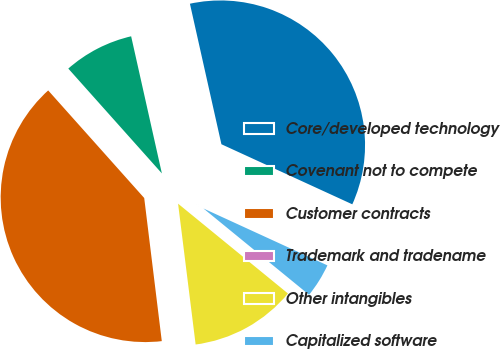Convert chart. <chart><loc_0><loc_0><loc_500><loc_500><pie_chart><fcel>Core/developed technology<fcel>Covenant not to compete<fcel>Customer contracts<fcel>Trademark and tradename<fcel>Other intangibles<fcel>Capitalized software<nl><fcel>35.36%<fcel>8.09%<fcel>40.35%<fcel>0.03%<fcel>12.12%<fcel>4.06%<nl></chart> 